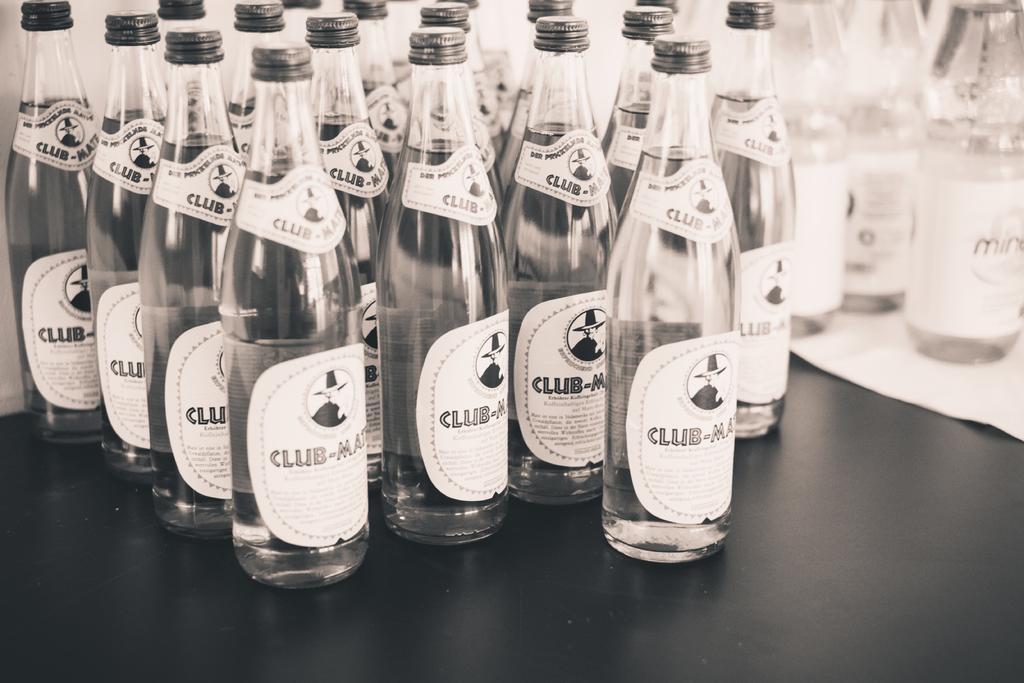Can you describe this image briefly? These are the bottles. There is a sticker on this bottle. 